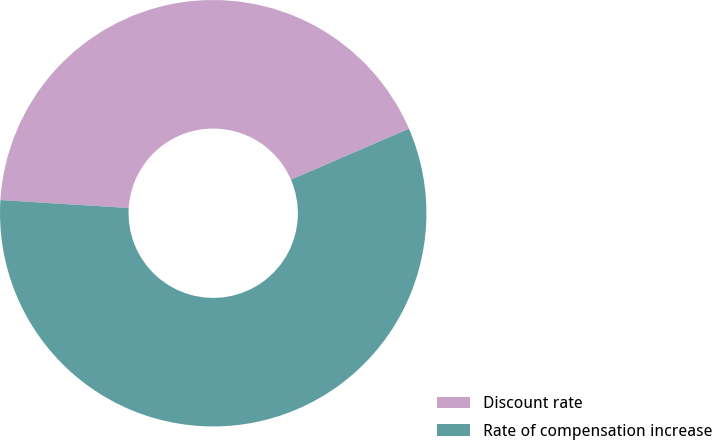Convert chart. <chart><loc_0><loc_0><loc_500><loc_500><pie_chart><fcel>Discount rate<fcel>Rate of compensation increase<nl><fcel>42.53%<fcel>57.47%<nl></chart> 